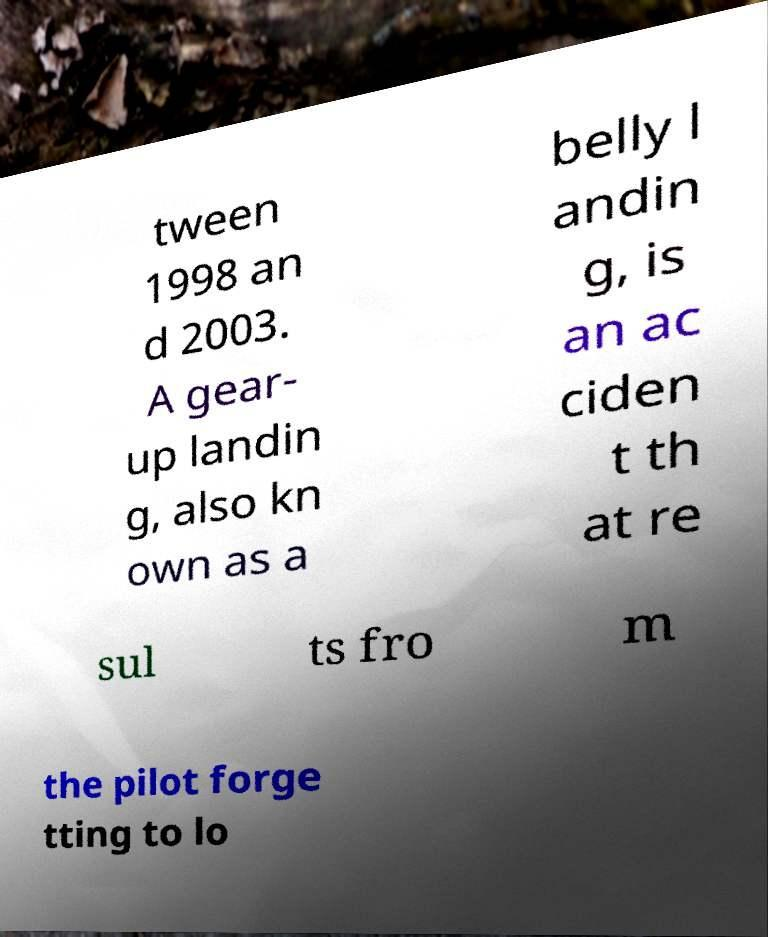What messages or text are displayed in this image? I need them in a readable, typed format. tween 1998 an d 2003. A gear- up landin g, also kn own as a belly l andin g, is an ac ciden t th at re sul ts fro m the pilot forge tting to lo 